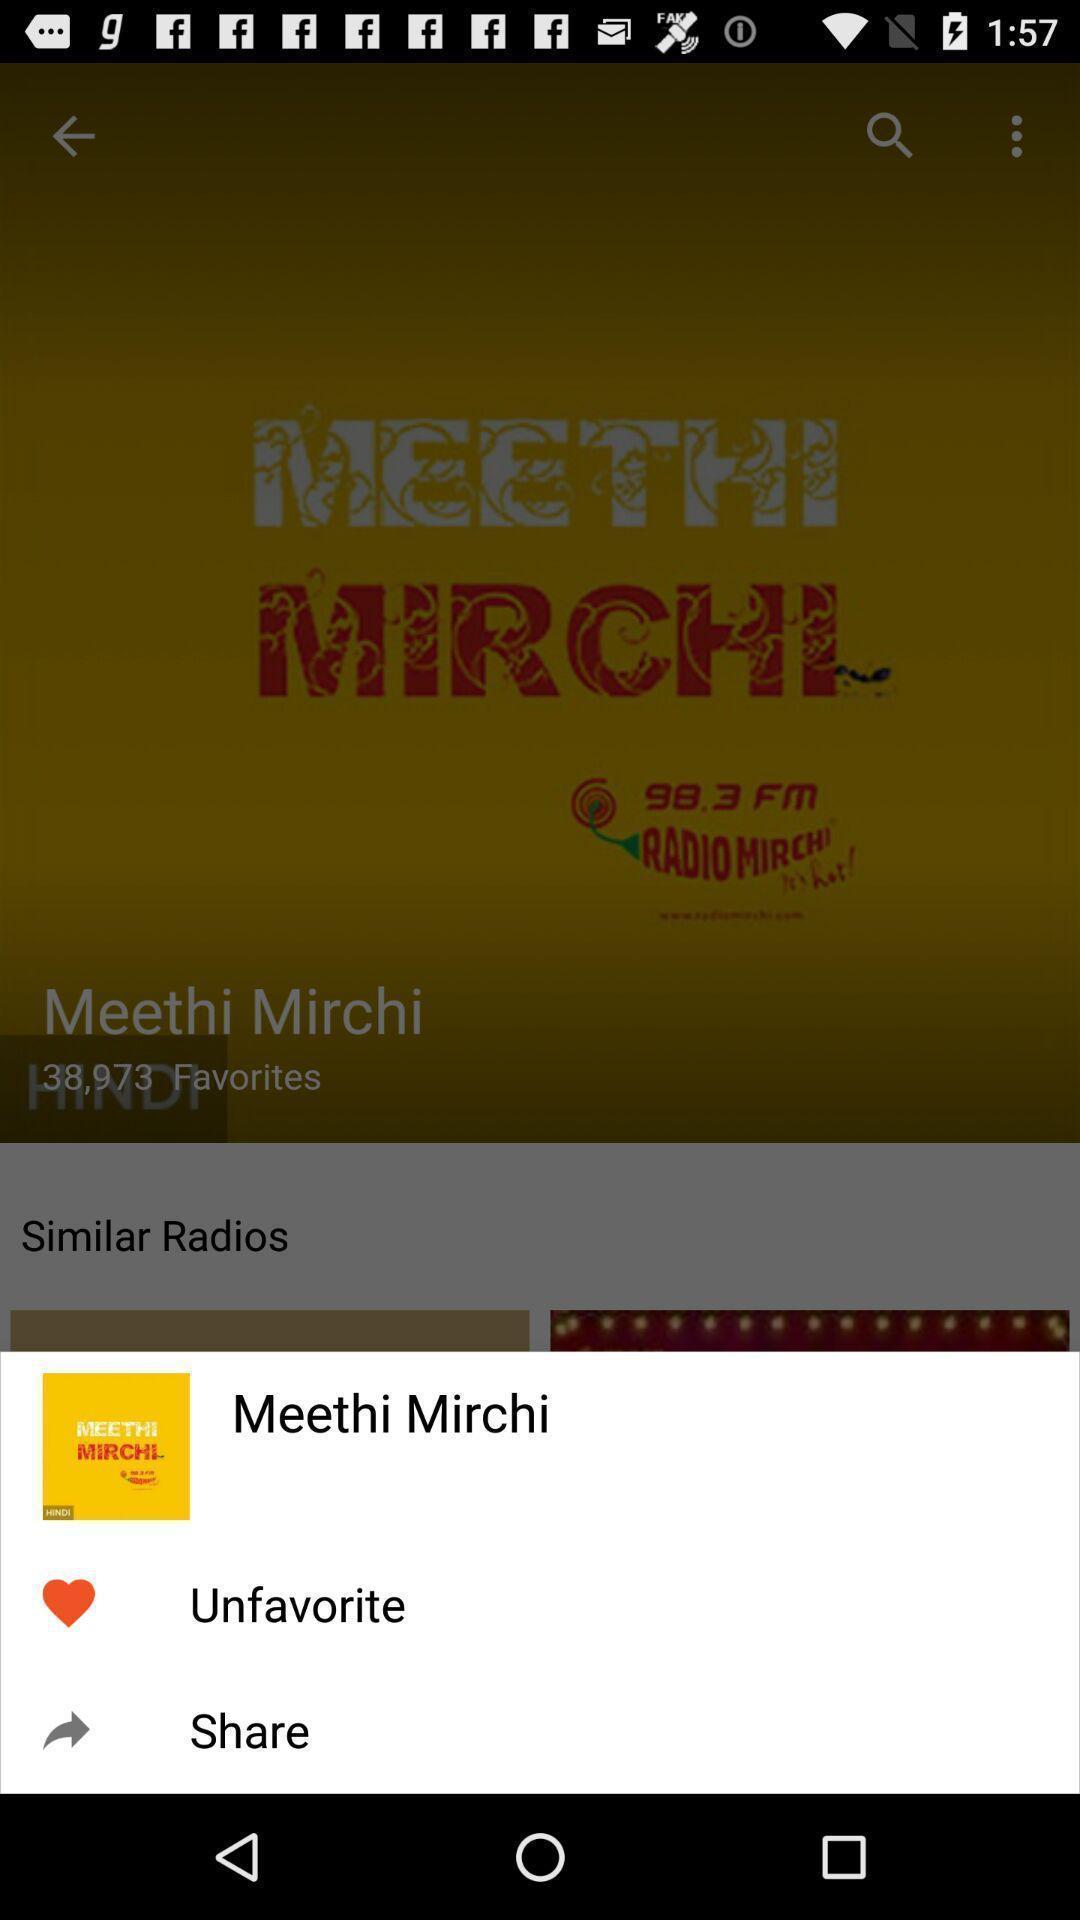Provide a textual representation of this image. Screen showing radio station to share. 